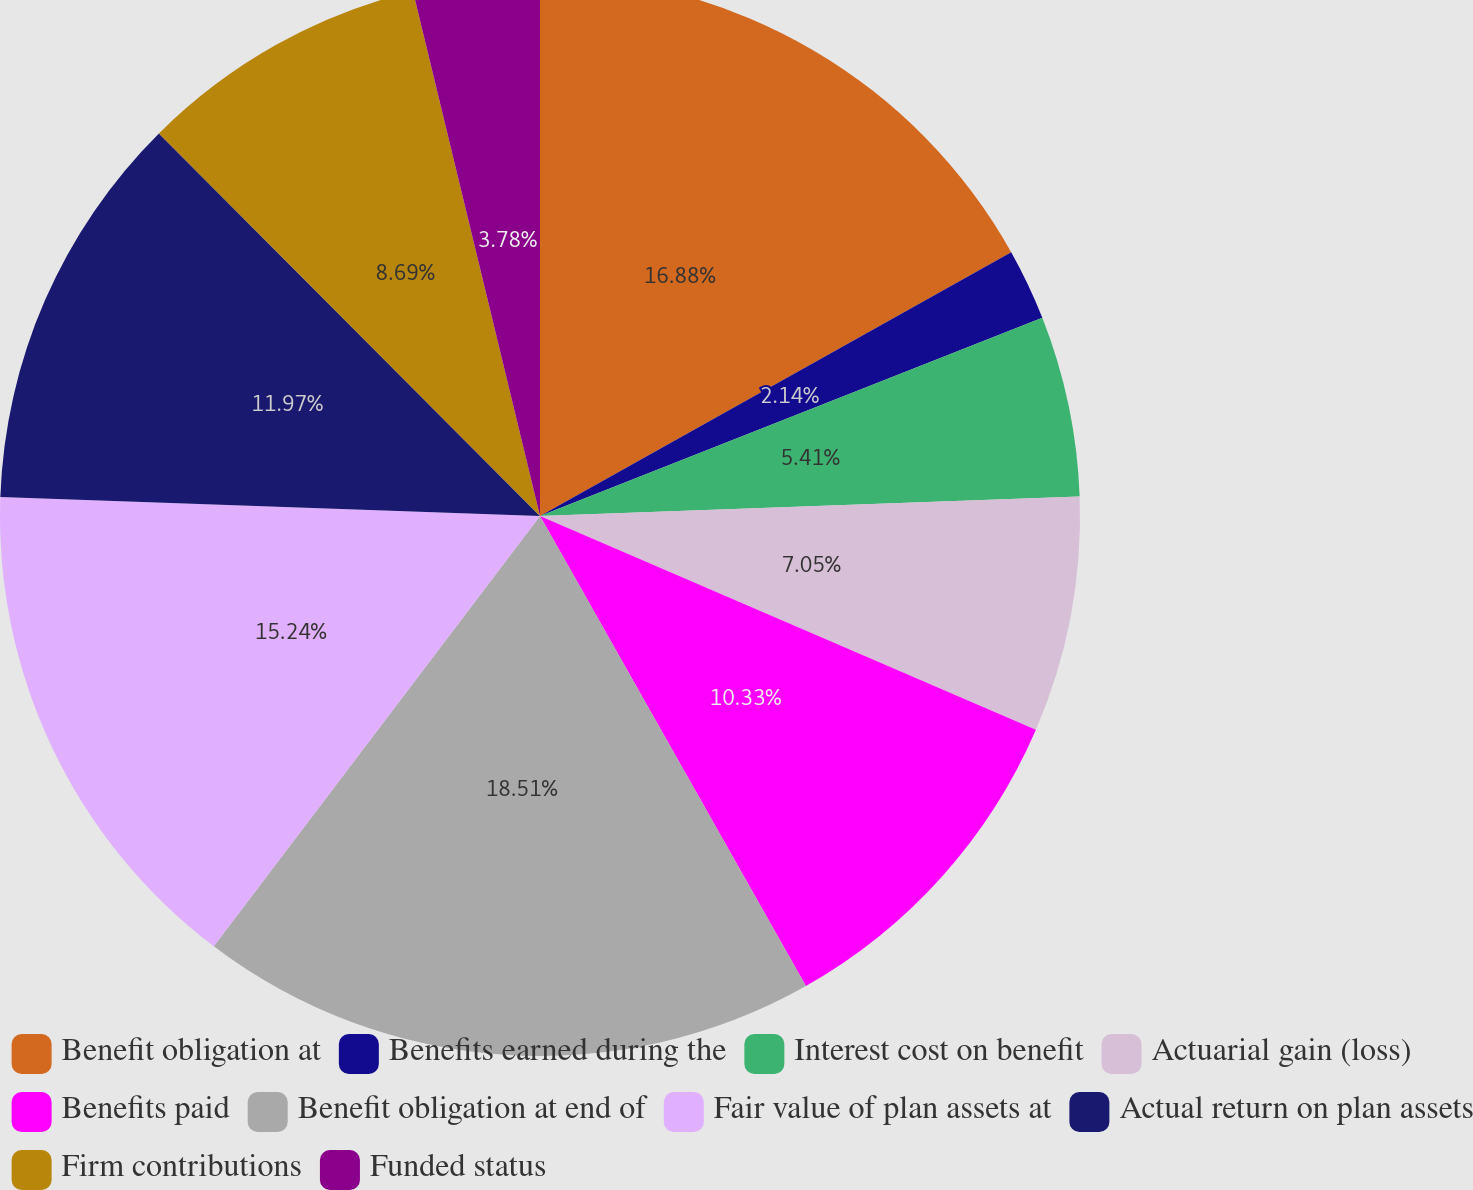Convert chart. <chart><loc_0><loc_0><loc_500><loc_500><pie_chart><fcel>Benefit obligation at<fcel>Benefits earned during the<fcel>Interest cost on benefit<fcel>Actuarial gain (loss)<fcel>Benefits paid<fcel>Benefit obligation at end of<fcel>Fair value of plan assets at<fcel>Actual return on plan assets<fcel>Firm contributions<fcel>Funded status<nl><fcel>16.88%<fcel>2.14%<fcel>5.41%<fcel>7.05%<fcel>10.33%<fcel>18.52%<fcel>15.24%<fcel>11.97%<fcel>8.69%<fcel>3.78%<nl></chart> 